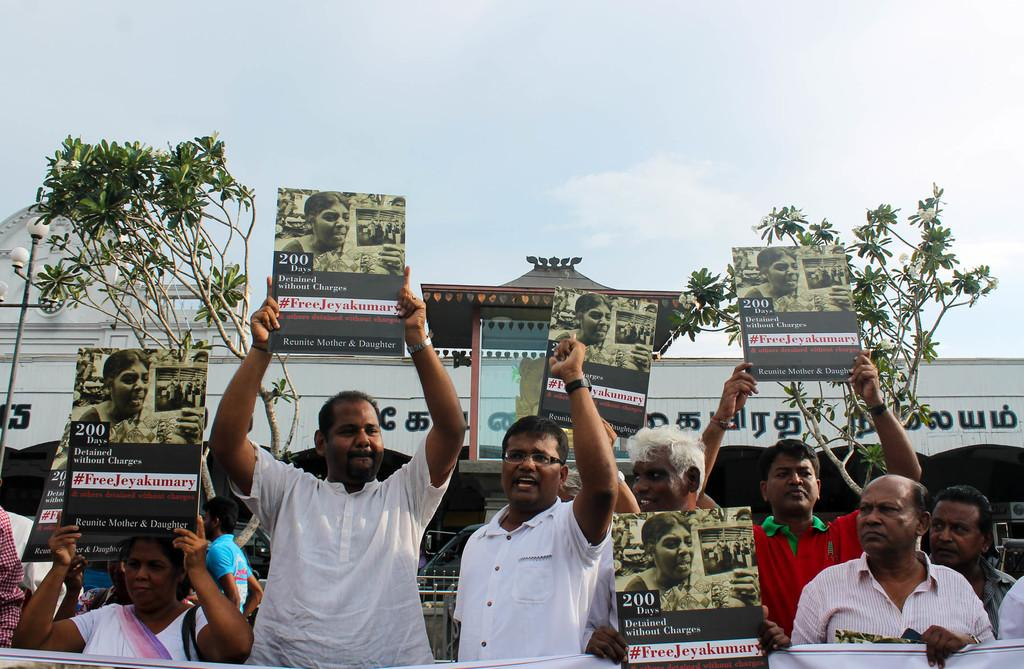What are the people in the image holding? The people in the image are holding posters. What can be seen on the posters? The posters have pictures and text on them. What can be seen in the background of the image? There are plants, a building, and the sky visible in the background of the image. How many pears are being eaten by the ants in the image? There are no ants or pears present in the image. Are the people in the image brothers? The relationship between the people in the image is not mentioned, so it cannot be determined if they are brothers. 